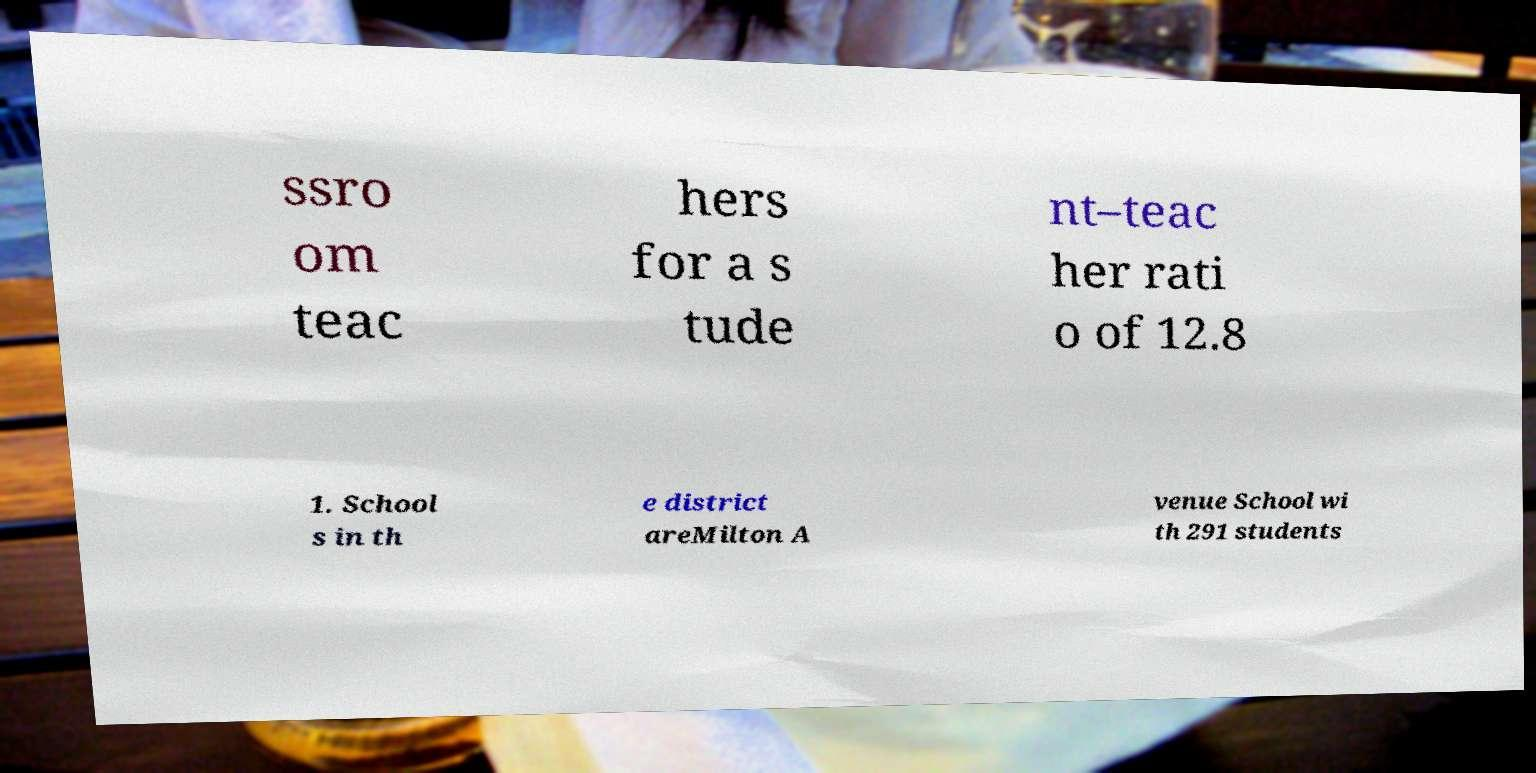Could you assist in decoding the text presented in this image and type it out clearly? ssro om teac hers for a s tude nt–teac her rati o of 12.8 1. School s in th e district areMilton A venue School wi th 291 students 